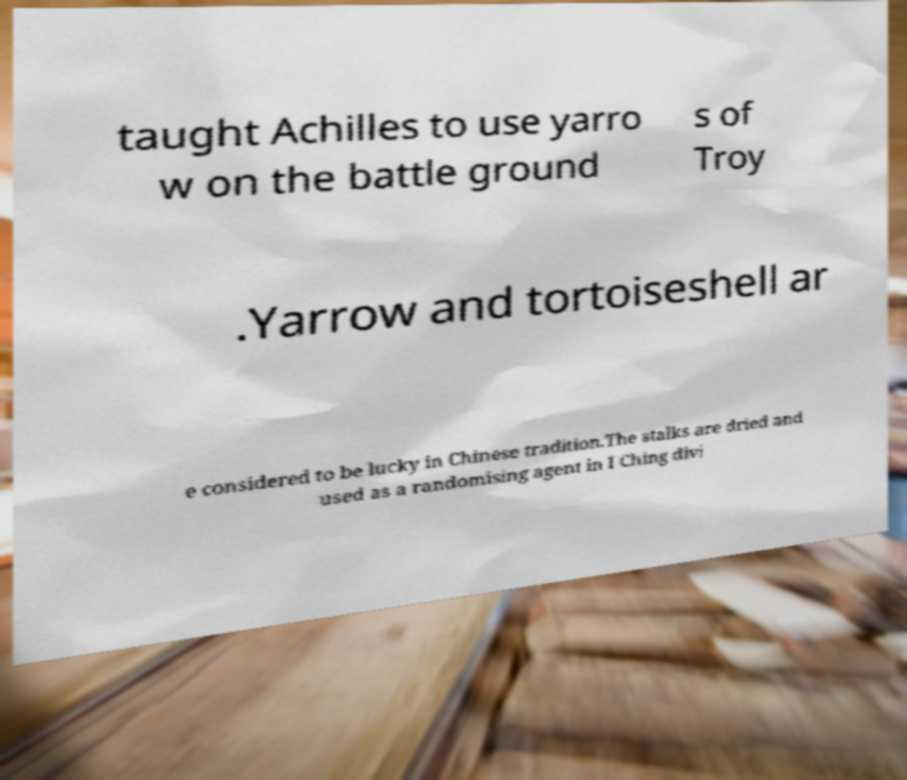Could you assist in decoding the text presented in this image and type it out clearly? taught Achilles to use yarro w on the battle ground s of Troy .Yarrow and tortoiseshell ar e considered to be lucky in Chinese tradition.The stalks are dried and used as a randomising agent in I Ching divi 